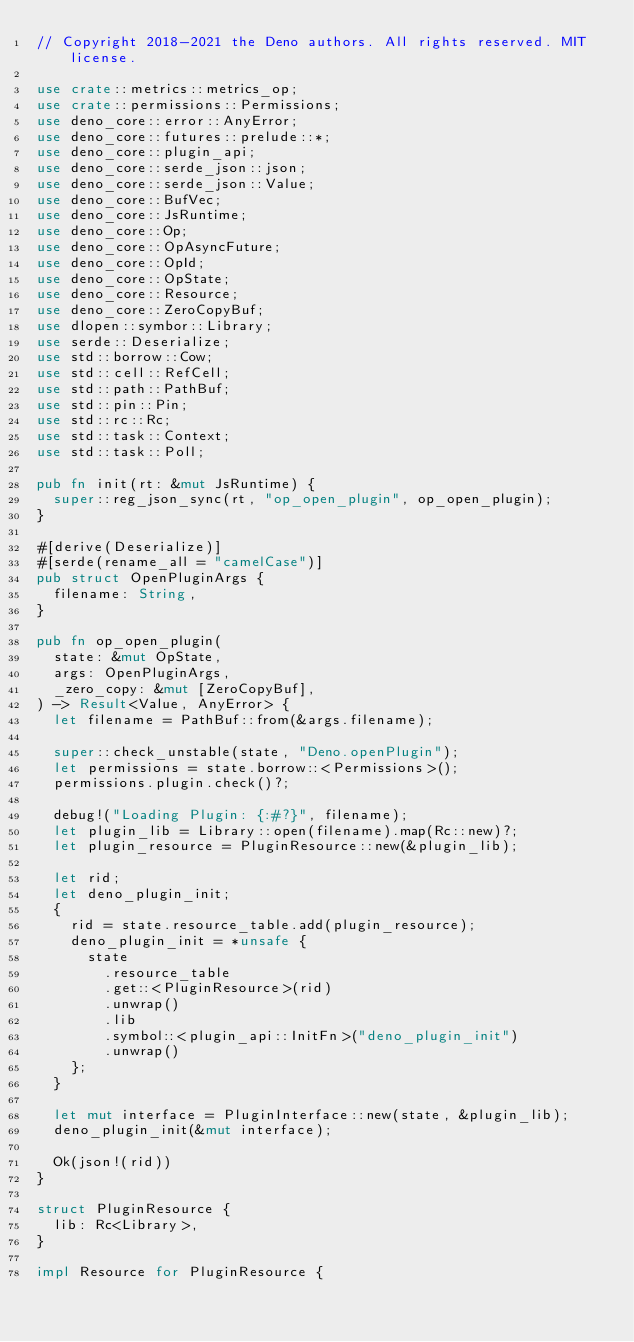Convert code to text. <code><loc_0><loc_0><loc_500><loc_500><_Rust_>// Copyright 2018-2021 the Deno authors. All rights reserved. MIT license.

use crate::metrics::metrics_op;
use crate::permissions::Permissions;
use deno_core::error::AnyError;
use deno_core::futures::prelude::*;
use deno_core::plugin_api;
use deno_core::serde_json::json;
use deno_core::serde_json::Value;
use deno_core::BufVec;
use deno_core::JsRuntime;
use deno_core::Op;
use deno_core::OpAsyncFuture;
use deno_core::OpId;
use deno_core::OpState;
use deno_core::Resource;
use deno_core::ZeroCopyBuf;
use dlopen::symbor::Library;
use serde::Deserialize;
use std::borrow::Cow;
use std::cell::RefCell;
use std::path::PathBuf;
use std::pin::Pin;
use std::rc::Rc;
use std::task::Context;
use std::task::Poll;

pub fn init(rt: &mut JsRuntime) {
  super::reg_json_sync(rt, "op_open_plugin", op_open_plugin);
}

#[derive(Deserialize)]
#[serde(rename_all = "camelCase")]
pub struct OpenPluginArgs {
  filename: String,
}

pub fn op_open_plugin(
  state: &mut OpState,
  args: OpenPluginArgs,
  _zero_copy: &mut [ZeroCopyBuf],
) -> Result<Value, AnyError> {
  let filename = PathBuf::from(&args.filename);

  super::check_unstable(state, "Deno.openPlugin");
  let permissions = state.borrow::<Permissions>();
  permissions.plugin.check()?;

  debug!("Loading Plugin: {:#?}", filename);
  let plugin_lib = Library::open(filename).map(Rc::new)?;
  let plugin_resource = PluginResource::new(&plugin_lib);

  let rid;
  let deno_plugin_init;
  {
    rid = state.resource_table.add(plugin_resource);
    deno_plugin_init = *unsafe {
      state
        .resource_table
        .get::<PluginResource>(rid)
        .unwrap()
        .lib
        .symbol::<plugin_api::InitFn>("deno_plugin_init")
        .unwrap()
    };
  }

  let mut interface = PluginInterface::new(state, &plugin_lib);
  deno_plugin_init(&mut interface);

  Ok(json!(rid))
}

struct PluginResource {
  lib: Rc<Library>,
}

impl Resource for PluginResource {</code> 